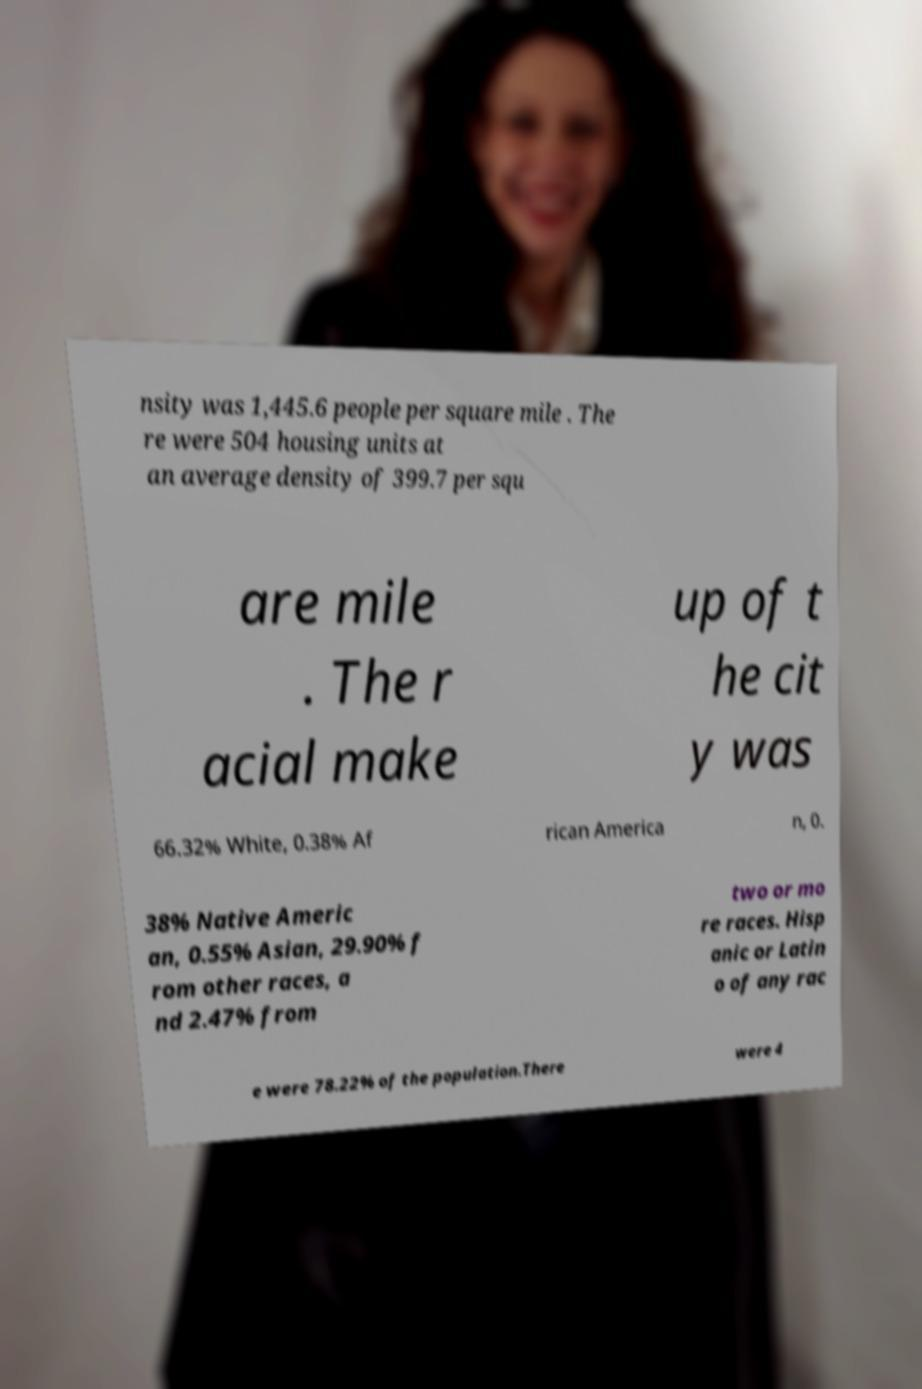Please identify and transcribe the text found in this image. nsity was 1,445.6 people per square mile . The re were 504 housing units at an average density of 399.7 per squ are mile . The r acial make up of t he cit y was 66.32% White, 0.38% Af rican America n, 0. 38% Native Americ an, 0.55% Asian, 29.90% f rom other races, a nd 2.47% from two or mo re races. Hisp anic or Latin o of any rac e were 78.22% of the population.There were 4 